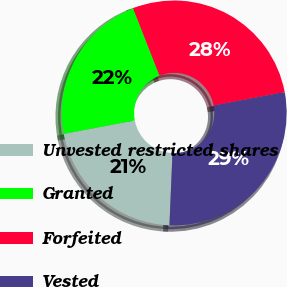<chart> <loc_0><loc_0><loc_500><loc_500><pie_chart><fcel>Unvested restricted shares<fcel>Granted<fcel>Forfeited<fcel>Vested<nl><fcel>21.36%<fcel>22.02%<fcel>27.98%<fcel>28.64%<nl></chart> 